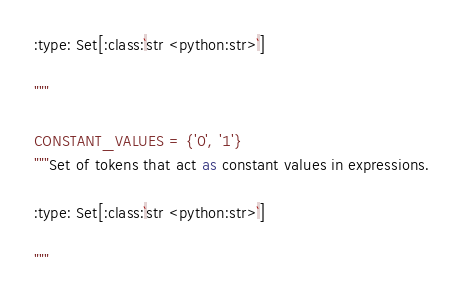<code> <loc_0><loc_0><loc_500><loc_500><_Python_>:type: Set[:class:`str <python:str>`]

"""

CONSTANT_VALUES = {'0', '1'}
"""Set of tokens that act as constant values in expressions.

:type: Set[:class:`str <python:str>`]

"""
</code> 